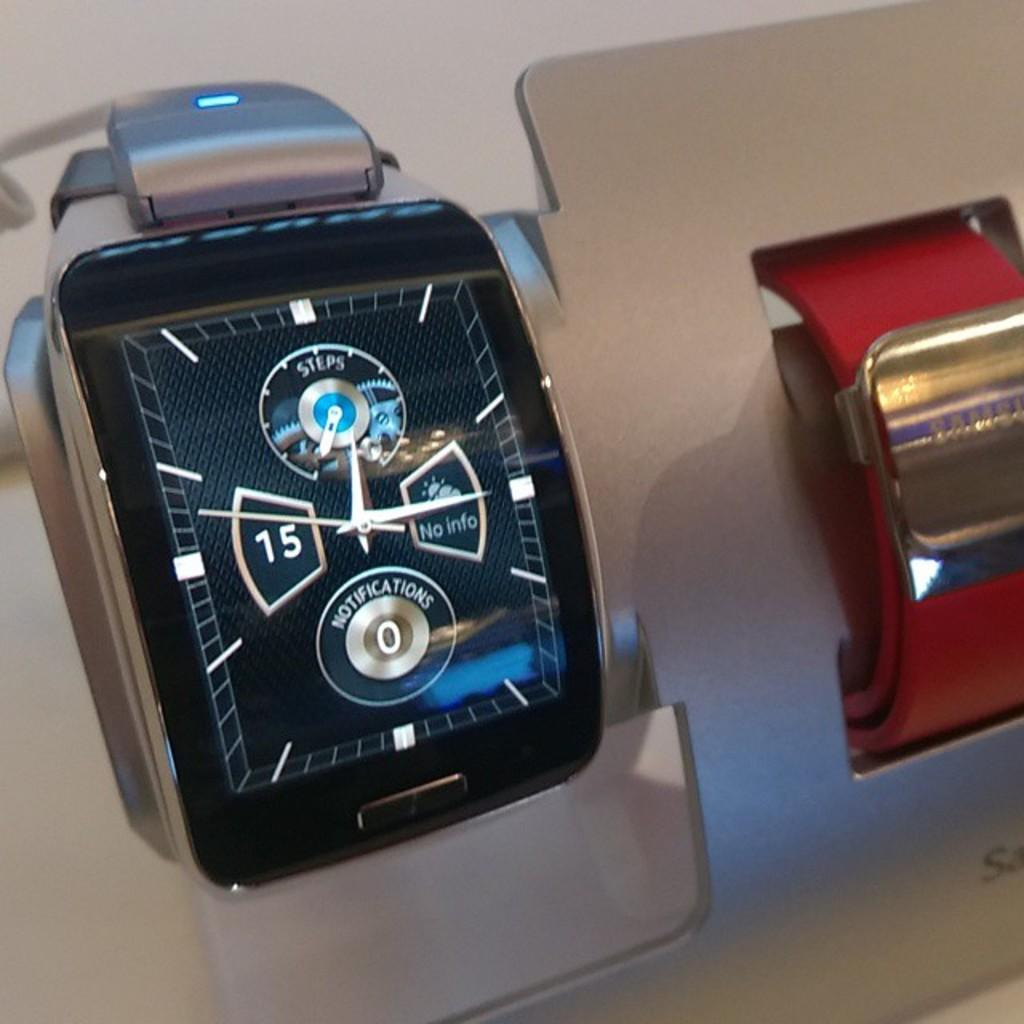<image>
Give a short and clear explanation of the subsequent image. A smart watch has a dial for steps, notifications, and weather. 